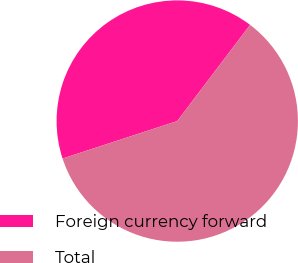<chart> <loc_0><loc_0><loc_500><loc_500><pie_chart><fcel>Foreign currency forward<fcel>Total<nl><fcel>40.34%<fcel>59.66%<nl></chart> 